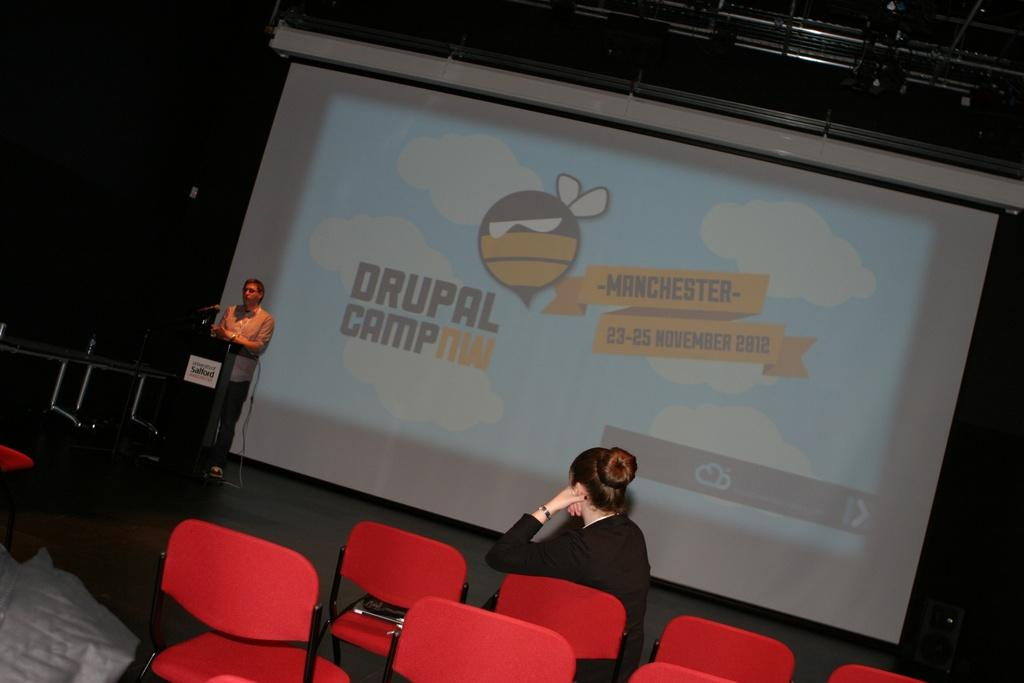How many people are in the image? There are two people in the image, one standing and one sitting on a chair. What type of furniture is present in the image? There are chairs in the image. What can be seen in the background of the image? There is a screen visible in the background of the image. What is located near the screen? There is a podium in the image. What is on the podium? There is a microphone on the podium. What type of crow is perched on the microphone in the image? There is no crow present in the image; it only features a person standing, a person sitting on a chair, chairs, a screen, a podium, and a microphone. 